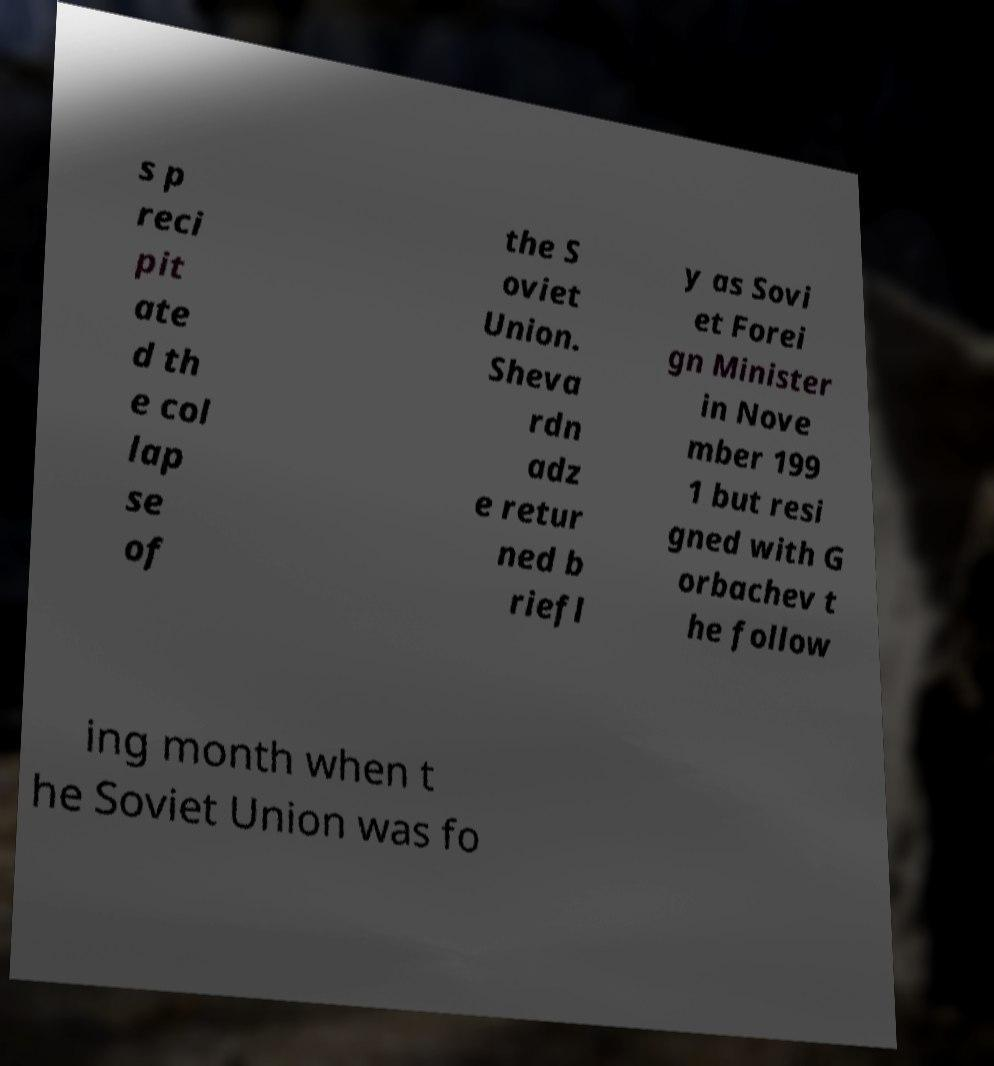Please identify and transcribe the text found in this image. s p reci pit ate d th e col lap se of the S oviet Union. Sheva rdn adz e retur ned b riefl y as Sovi et Forei gn Minister in Nove mber 199 1 but resi gned with G orbachev t he follow ing month when t he Soviet Union was fo 